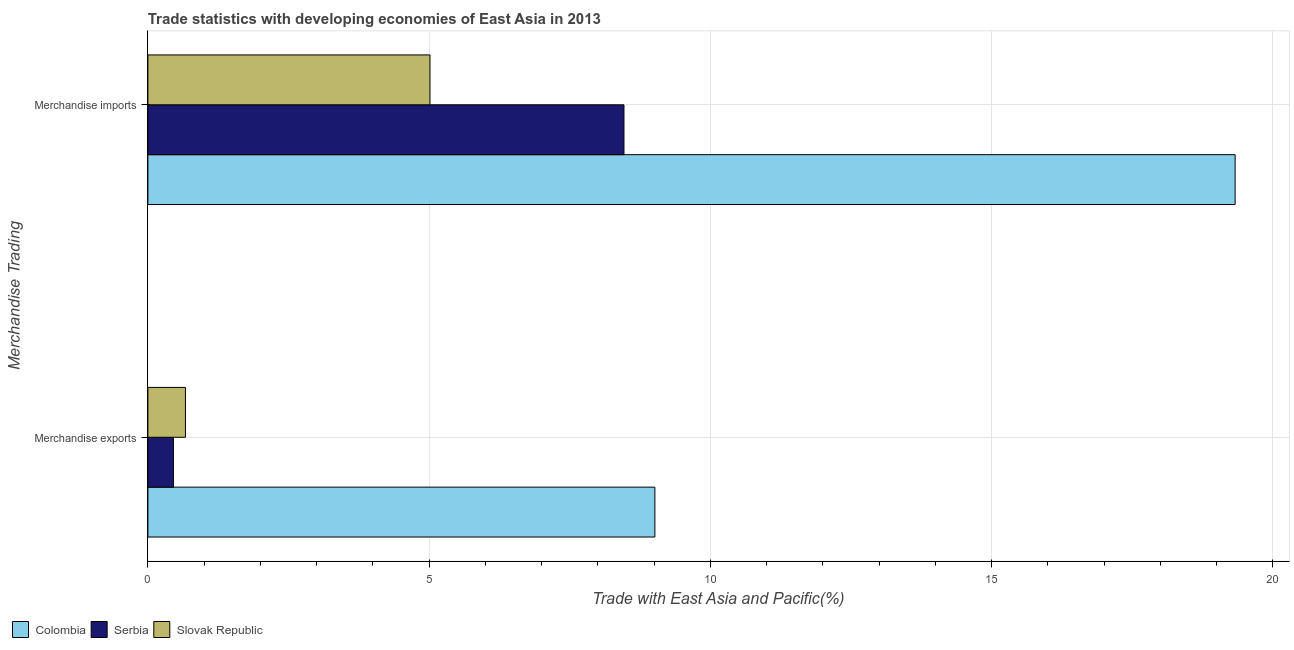Are the number of bars per tick equal to the number of legend labels?
Your answer should be compact. Yes. Are the number of bars on each tick of the Y-axis equal?
Offer a very short reply. Yes. How many bars are there on the 2nd tick from the bottom?
Ensure brevity in your answer.  3. What is the merchandise exports in Colombia?
Your answer should be compact. 9.01. Across all countries, what is the maximum merchandise exports?
Make the answer very short. 9.01. Across all countries, what is the minimum merchandise imports?
Offer a very short reply. 5.02. In which country was the merchandise exports minimum?
Provide a succinct answer. Serbia. What is the total merchandise exports in the graph?
Give a very brief answer. 10.14. What is the difference between the merchandise imports in Colombia and that in Serbia?
Your answer should be very brief. 10.86. What is the difference between the merchandise exports in Colombia and the merchandise imports in Slovak Republic?
Your response must be concise. 4. What is the average merchandise exports per country?
Provide a succinct answer. 3.38. What is the difference between the merchandise imports and merchandise exports in Colombia?
Your answer should be compact. 10.32. What is the ratio of the merchandise imports in Slovak Republic to that in Serbia?
Provide a short and direct response. 0.59. Is the merchandise imports in Slovak Republic less than that in Colombia?
Offer a terse response. Yes. In how many countries, is the merchandise exports greater than the average merchandise exports taken over all countries?
Your answer should be very brief. 1. What does the 2nd bar from the top in Merchandise imports represents?
Provide a short and direct response. Serbia. What does the 2nd bar from the bottom in Merchandise exports represents?
Provide a succinct answer. Serbia. Are the values on the major ticks of X-axis written in scientific E-notation?
Your answer should be compact. No. Does the graph contain grids?
Your answer should be very brief. Yes. Where does the legend appear in the graph?
Provide a short and direct response. Bottom left. How many legend labels are there?
Offer a terse response. 3. How are the legend labels stacked?
Provide a succinct answer. Horizontal. What is the title of the graph?
Your answer should be compact. Trade statistics with developing economies of East Asia in 2013. Does "Argentina" appear as one of the legend labels in the graph?
Your response must be concise. No. What is the label or title of the X-axis?
Make the answer very short. Trade with East Asia and Pacific(%). What is the label or title of the Y-axis?
Your answer should be compact. Merchandise Trading. What is the Trade with East Asia and Pacific(%) in Colombia in Merchandise exports?
Your response must be concise. 9.01. What is the Trade with East Asia and Pacific(%) of Serbia in Merchandise exports?
Provide a succinct answer. 0.45. What is the Trade with East Asia and Pacific(%) in Slovak Republic in Merchandise exports?
Your answer should be compact. 0.67. What is the Trade with East Asia and Pacific(%) of Colombia in Merchandise imports?
Your response must be concise. 19.33. What is the Trade with East Asia and Pacific(%) in Serbia in Merchandise imports?
Ensure brevity in your answer.  8.46. What is the Trade with East Asia and Pacific(%) in Slovak Republic in Merchandise imports?
Keep it short and to the point. 5.02. Across all Merchandise Trading, what is the maximum Trade with East Asia and Pacific(%) of Colombia?
Your answer should be very brief. 19.33. Across all Merchandise Trading, what is the maximum Trade with East Asia and Pacific(%) in Serbia?
Give a very brief answer. 8.46. Across all Merchandise Trading, what is the maximum Trade with East Asia and Pacific(%) in Slovak Republic?
Give a very brief answer. 5.02. Across all Merchandise Trading, what is the minimum Trade with East Asia and Pacific(%) in Colombia?
Your answer should be compact. 9.01. Across all Merchandise Trading, what is the minimum Trade with East Asia and Pacific(%) in Serbia?
Make the answer very short. 0.45. Across all Merchandise Trading, what is the minimum Trade with East Asia and Pacific(%) in Slovak Republic?
Your response must be concise. 0.67. What is the total Trade with East Asia and Pacific(%) in Colombia in the graph?
Provide a short and direct response. 28.34. What is the total Trade with East Asia and Pacific(%) of Serbia in the graph?
Your answer should be compact. 8.92. What is the total Trade with East Asia and Pacific(%) in Slovak Republic in the graph?
Offer a terse response. 5.68. What is the difference between the Trade with East Asia and Pacific(%) in Colombia in Merchandise exports and that in Merchandise imports?
Your answer should be very brief. -10.31. What is the difference between the Trade with East Asia and Pacific(%) of Serbia in Merchandise exports and that in Merchandise imports?
Give a very brief answer. -8.01. What is the difference between the Trade with East Asia and Pacific(%) of Slovak Republic in Merchandise exports and that in Merchandise imports?
Offer a very short reply. -4.35. What is the difference between the Trade with East Asia and Pacific(%) in Colombia in Merchandise exports and the Trade with East Asia and Pacific(%) in Serbia in Merchandise imports?
Ensure brevity in your answer.  0.55. What is the difference between the Trade with East Asia and Pacific(%) in Colombia in Merchandise exports and the Trade with East Asia and Pacific(%) in Slovak Republic in Merchandise imports?
Keep it short and to the point. 4. What is the difference between the Trade with East Asia and Pacific(%) in Serbia in Merchandise exports and the Trade with East Asia and Pacific(%) in Slovak Republic in Merchandise imports?
Your answer should be compact. -4.56. What is the average Trade with East Asia and Pacific(%) of Colombia per Merchandise Trading?
Make the answer very short. 14.17. What is the average Trade with East Asia and Pacific(%) in Serbia per Merchandise Trading?
Your answer should be compact. 4.46. What is the average Trade with East Asia and Pacific(%) in Slovak Republic per Merchandise Trading?
Your answer should be very brief. 2.84. What is the difference between the Trade with East Asia and Pacific(%) of Colombia and Trade with East Asia and Pacific(%) of Serbia in Merchandise exports?
Offer a terse response. 8.56. What is the difference between the Trade with East Asia and Pacific(%) in Colombia and Trade with East Asia and Pacific(%) in Slovak Republic in Merchandise exports?
Offer a terse response. 8.35. What is the difference between the Trade with East Asia and Pacific(%) in Serbia and Trade with East Asia and Pacific(%) in Slovak Republic in Merchandise exports?
Keep it short and to the point. -0.21. What is the difference between the Trade with East Asia and Pacific(%) in Colombia and Trade with East Asia and Pacific(%) in Serbia in Merchandise imports?
Your response must be concise. 10.86. What is the difference between the Trade with East Asia and Pacific(%) of Colombia and Trade with East Asia and Pacific(%) of Slovak Republic in Merchandise imports?
Keep it short and to the point. 14.31. What is the difference between the Trade with East Asia and Pacific(%) of Serbia and Trade with East Asia and Pacific(%) of Slovak Republic in Merchandise imports?
Your answer should be very brief. 3.45. What is the ratio of the Trade with East Asia and Pacific(%) of Colombia in Merchandise exports to that in Merchandise imports?
Offer a terse response. 0.47. What is the ratio of the Trade with East Asia and Pacific(%) of Serbia in Merchandise exports to that in Merchandise imports?
Give a very brief answer. 0.05. What is the ratio of the Trade with East Asia and Pacific(%) of Slovak Republic in Merchandise exports to that in Merchandise imports?
Give a very brief answer. 0.13. What is the difference between the highest and the second highest Trade with East Asia and Pacific(%) of Colombia?
Provide a succinct answer. 10.31. What is the difference between the highest and the second highest Trade with East Asia and Pacific(%) of Serbia?
Give a very brief answer. 8.01. What is the difference between the highest and the second highest Trade with East Asia and Pacific(%) of Slovak Republic?
Offer a terse response. 4.35. What is the difference between the highest and the lowest Trade with East Asia and Pacific(%) in Colombia?
Your response must be concise. 10.31. What is the difference between the highest and the lowest Trade with East Asia and Pacific(%) in Serbia?
Offer a very short reply. 8.01. What is the difference between the highest and the lowest Trade with East Asia and Pacific(%) in Slovak Republic?
Give a very brief answer. 4.35. 